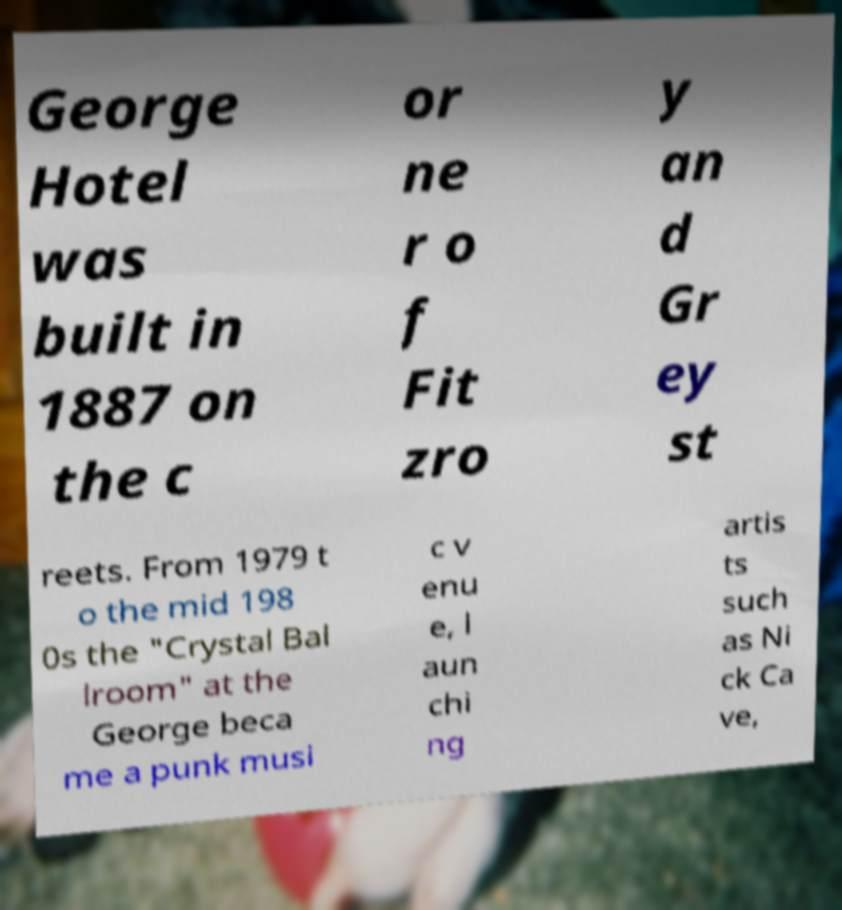Please identify and transcribe the text found in this image. George Hotel was built in 1887 on the c or ne r o f Fit zro y an d Gr ey st reets. From 1979 t o the mid 198 0s the "Crystal Bal lroom" at the George beca me a punk musi c v enu e, l aun chi ng artis ts such as Ni ck Ca ve, 